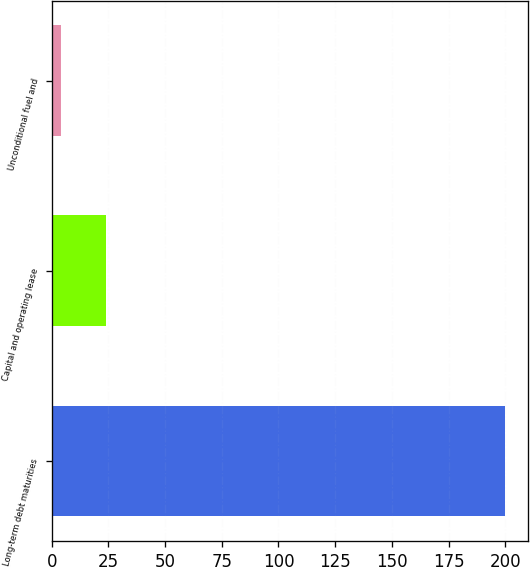Convert chart to OTSL. <chart><loc_0><loc_0><loc_500><loc_500><bar_chart><fcel>Long-term debt maturities<fcel>Capital and operating lease<fcel>Unconditional fuel and<nl><fcel>200<fcel>24<fcel>4<nl></chart> 